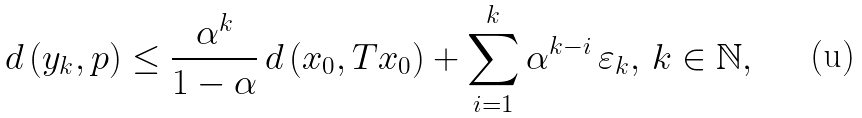Convert formula to latex. <formula><loc_0><loc_0><loc_500><loc_500>d \left ( y _ { k } , p \right ) \leq \frac { \alpha ^ { k } } { 1 - \alpha } \, d \left ( x _ { 0 } , T x _ { 0 } \right ) + \sum _ { i = 1 } ^ { k } \alpha ^ { k - i } \, \varepsilon _ { k } , \, k \in \mathbb { N } ,</formula> 